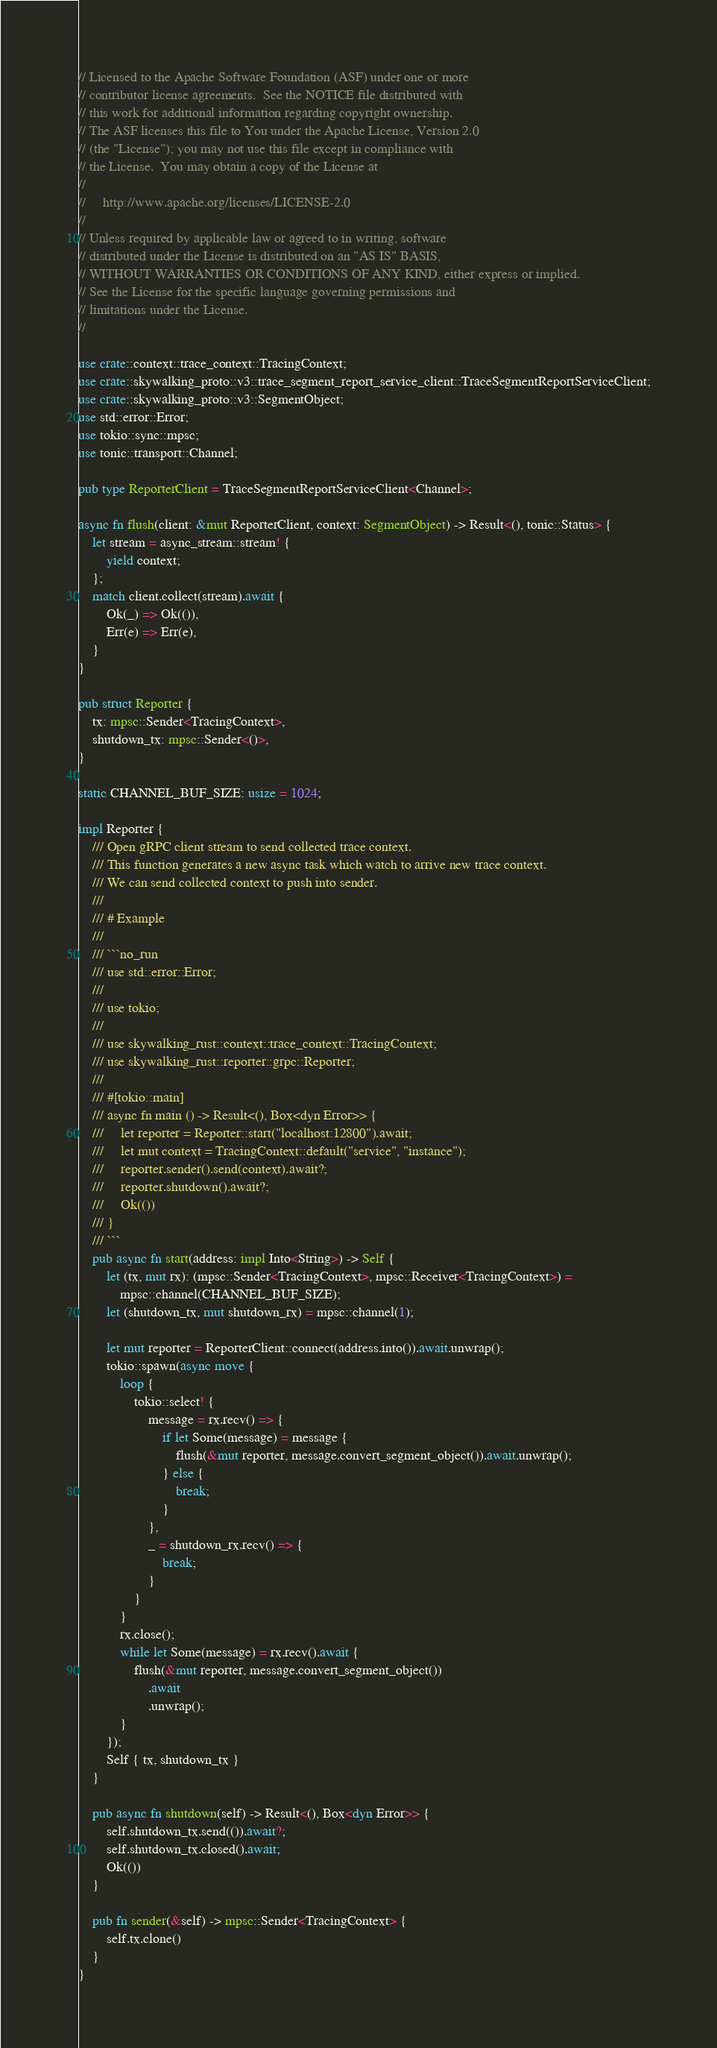<code> <loc_0><loc_0><loc_500><loc_500><_Rust_>// Licensed to the Apache Software Foundation (ASF) under one or more
// contributor license agreements.  See the NOTICE file distributed with
// this work for additional information regarding copyright ownership.
// The ASF licenses this file to You under the Apache License, Version 2.0
// (the "License"); you may not use this file except in compliance with
// the License.  You may obtain a copy of the License at
//
//     http://www.apache.org/licenses/LICENSE-2.0
//
// Unless required by applicable law or agreed to in writing, software
// distributed under the License is distributed on an "AS IS" BASIS,
// WITHOUT WARRANTIES OR CONDITIONS OF ANY KIND, either express or implied.
// See the License for the specific language governing permissions and
// limitations under the License.
//

use crate::context::trace_context::TracingContext;
use crate::skywalking_proto::v3::trace_segment_report_service_client::TraceSegmentReportServiceClient;
use crate::skywalking_proto::v3::SegmentObject;
use std::error::Error;
use tokio::sync::mpsc;
use tonic::transport::Channel;

pub type ReporterClient = TraceSegmentReportServiceClient<Channel>;

async fn flush(client: &mut ReporterClient, context: SegmentObject) -> Result<(), tonic::Status> {
    let stream = async_stream::stream! {
        yield context;
    };
    match client.collect(stream).await {
        Ok(_) => Ok(()),
        Err(e) => Err(e),
    }
}

pub struct Reporter {
    tx: mpsc::Sender<TracingContext>,
    shutdown_tx: mpsc::Sender<()>,
}

static CHANNEL_BUF_SIZE: usize = 1024;

impl Reporter {
    /// Open gRPC client stream to send collected trace context.
    /// This function generates a new async task which watch to arrive new trace context.
    /// We can send collected context to push into sender.
    ///
    /// # Example
    ///
    /// ```no_run
    /// use std::error::Error;
    ///
    /// use tokio;
    ///
    /// use skywalking_rust::context::trace_context::TracingContext;
    /// use skywalking_rust::reporter::grpc::Reporter;
    ///
    /// #[tokio::main]
    /// async fn main () -> Result<(), Box<dyn Error>> {
    ///     let reporter = Reporter::start("localhost:12800").await;
    ///     let mut context = TracingContext::default("service", "instance");
    ///     reporter.sender().send(context).await?;
    ///     reporter.shutdown().await?;
    ///     Ok(())
    /// }
    /// ```
    pub async fn start(address: impl Into<String>) -> Self {
        let (tx, mut rx): (mpsc::Sender<TracingContext>, mpsc::Receiver<TracingContext>) =
            mpsc::channel(CHANNEL_BUF_SIZE);
        let (shutdown_tx, mut shutdown_rx) = mpsc::channel(1);

        let mut reporter = ReporterClient::connect(address.into()).await.unwrap();
        tokio::spawn(async move {
            loop {
                tokio::select! {
                    message = rx.recv() => {
                        if let Some(message) = message {
                            flush(&mut reporter, message.convert_segment_object()).await.unwrap();
                        } else {
                            break;
                        }
                    },
                    _ = shutdown_rx.recv() => {
                        break;
                    }
                }
            }
            rx.close();
            while let Some(message) = rx.recv().await {
                flush(&mut reporter, message.convert_segment_object())
                    .await
                    .unwrap();
            }
        });
        Self { tx, shutdown_tx }
    }

    pub async fn shutdown(self) -> Result<(), Box<dyn Error>> {
        self.shutdown_tx.send(()).await?;
        self.shutdown_tx.closed().await;
        Ok(())
    }

    pub fn sender(&self) -> mpsc::Sender<TracingContext> {
        self.tx.clone()
    }
}
</code> 